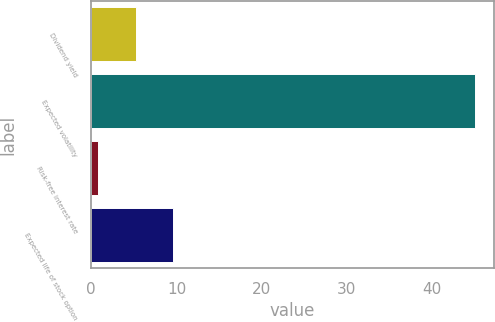Convert chart to OTSL. <chart><loc_0><loc_0><loc_500><loc_500><bar_chart><fcel>Dividend yield<fcel>Expected volatility<fcel>Risk-free interest rate<fcel>Expected life of stock option<nl><fcel>5.22<fcel>45<fcel>0.8<fcel>9.64<nl></chart> 